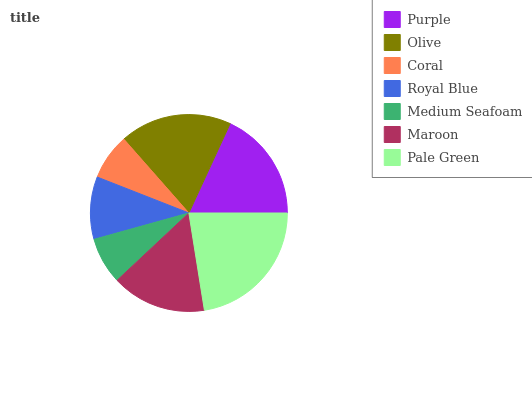Is Coral the minimum?
Answer yes or no. Yes. Is Pale Green the maximum?
Answer yes or no. Yes. Is Olive the minimum?
Answer yes or no. No. Is Olive the maximum?
Answer yes or no. No. Is Olive greater than Purple?
Answer yes or no. Yes. Is Purple less than Olive?
Answer yes or no. Yes. Is Purple greater than Olive?
Answer yes or no. No. Is Olive less than Purple?
Answer yes or no. No. Is Maroon the high median?
Answer yes or no. Yes. Is Maroon the low median?
Answer yes or no. Yes. Is Olive the high median?
Answer yes or no. No. Is Coral the low median?
Answer yes or no. No. 